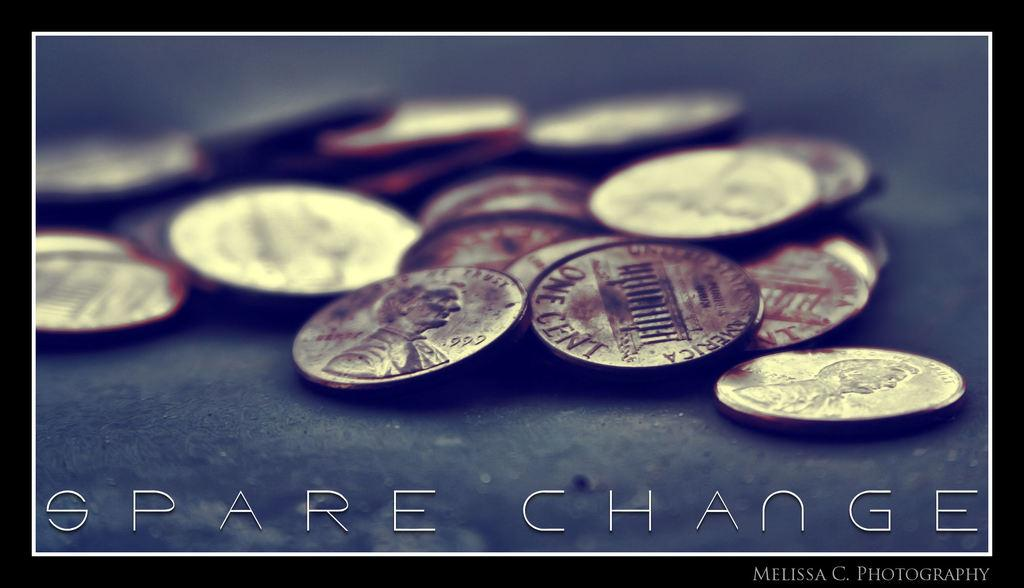<image>
Describe the image concisely. Photo of some coins on a street and the words "Spare Change" near the bottom. 